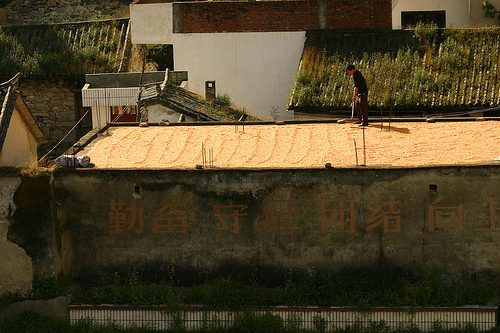<image>
Can you confirm if the man is above the sand? No. The man is not positioned above the sand. The vertical arrangement shows a different relationship. 